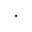Convert formula to latex. <formula><loc_0><loc_0><loc_500><loc_500>\cdot</formula> 